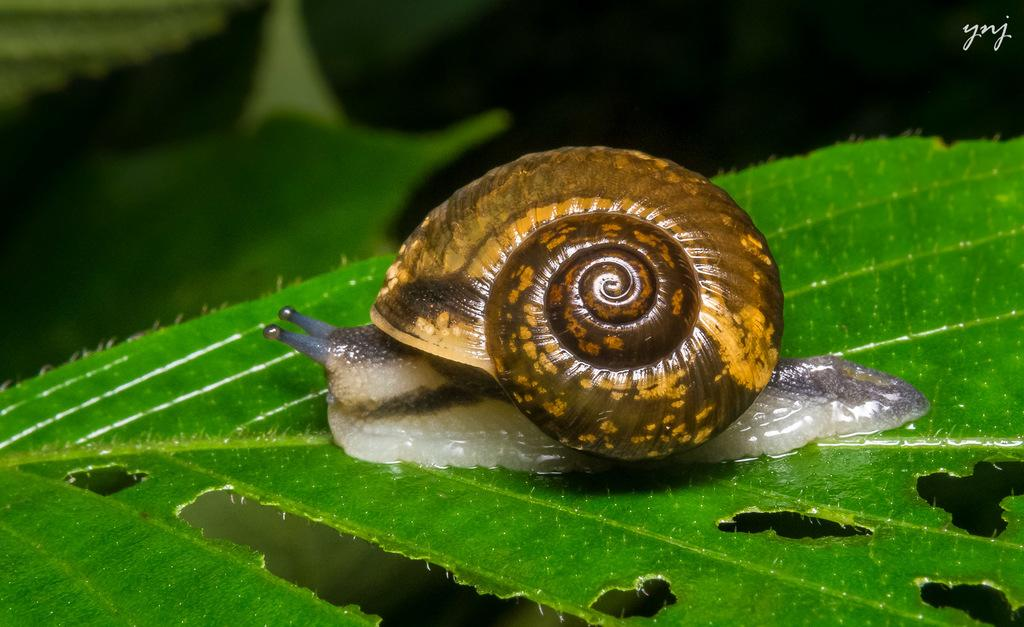What is the main subject of the image? There is a snail in the image. Where is the snail located? The snail is on a leaf. What can be observed about the background of the image? The background of the image is dark. What type of bomb is the snail carrying on the leaf? There is no bomb present in the image; it features a snail on a leaf. Can you tell me how many kitties are hiding behind the leaf in the image? There are no kitties present in the image; it features a snail on a leaf. 